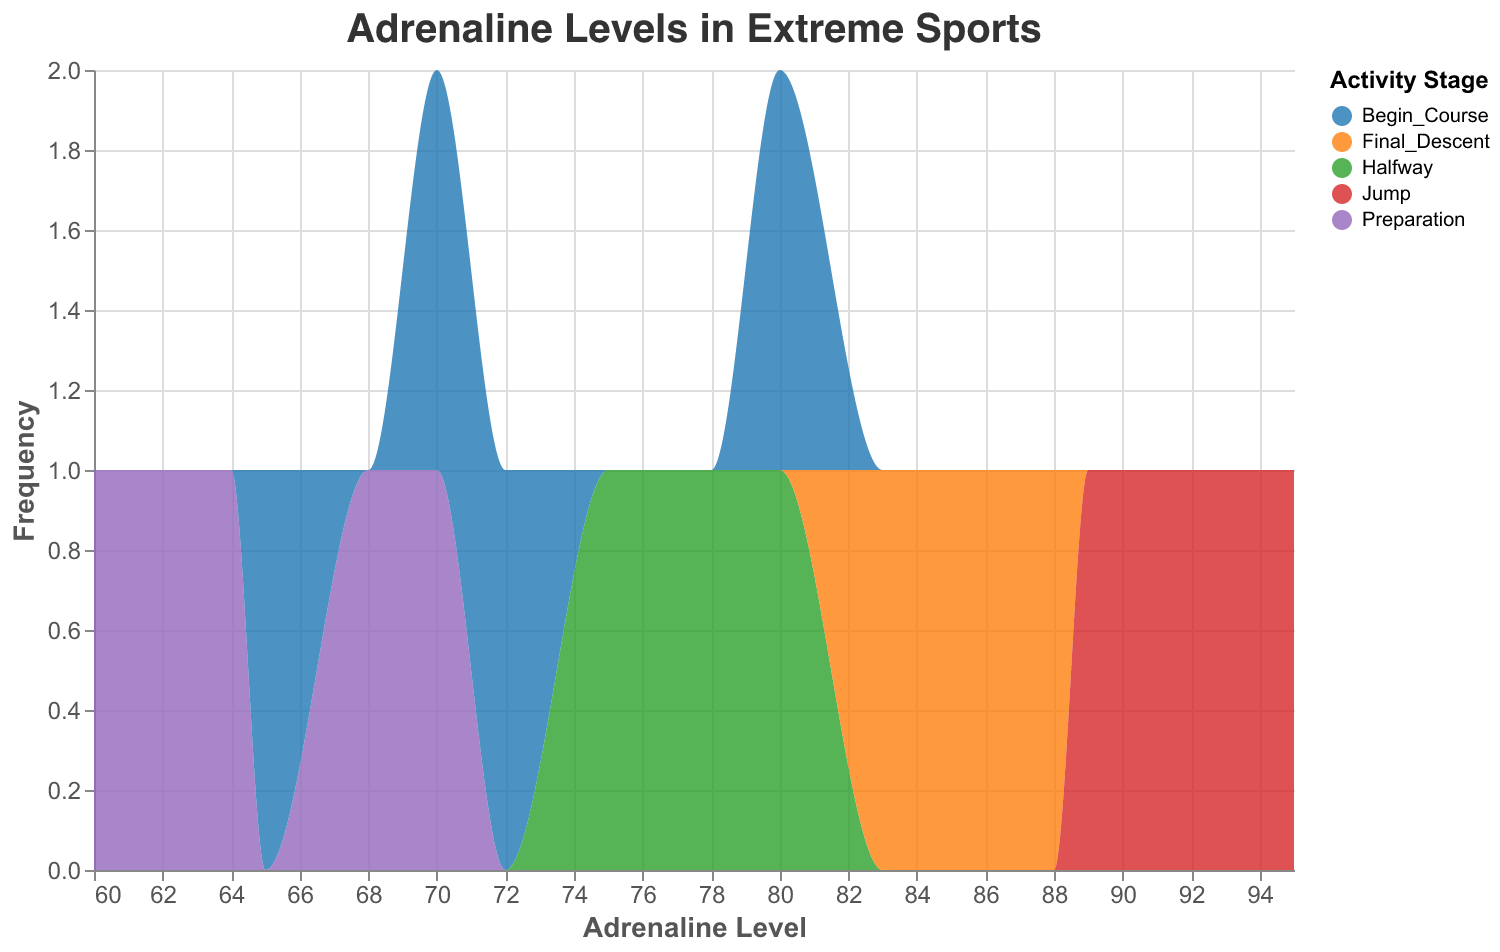What is the title of the figure? The title is a basic element of the figure. It is typically displayed at the top and clearly indicates the subject of the visualization.
Answer: Adrenaline Levels in Extreme Sports How many different activity stages are represented in the figure? Observing the legend or the color coding in the figure, each distinct color corresponds to a unique activity stage.
Answer: 5 Which activity stage has the highest recorded adrenaline level? By looking at the x-axis (Adrenaline Level) and observing where the highest value is, we can identify the corresponding activity stage through the color coding.
Answer: Jump During which activity stage are the adrenaline levels most frequently recorded between 85 and 95? By examining the distribution area on the figure within the range of 85-95 on the x-axis (Adrenaline Level), we can observe which activity stage's color dominates within this interval.
Answer: Jump What is the difference between the highest and lowest recorded adrenaline levels? To find the difference, identify the maximum value and minimum value on the x-axis, then subtract the minimum from the maximum. Maximum adrenaline level seen is 95, and minimum is 60, so the difference is 95 - 60.
Answer: 35 Which activity stage shows the widest spread of adrenaline levels? Looking for the span of the curve for each activity stage along the x-axis (Adrenaline Level), we indicate which color (activity stage) covers the most range.
Answer: Halfway Is the frequency of adrenaline levels more spread out or concentrated for the "Preparation" stage? By assessing the figure, especially the y-axis representing frequency and observing the color segment for "Preparation" stage, we can see if the area is narrow and high (concentrated) or wide and low (spread out).
Answer: Spread out How does the distribution of adrenaline levels for "Final Descent" compare to "Begin Course"? To compare the distributions, look at the areas under the curve for both stages and their shapes. "Final Descent" tends to have higher adrenaline levels more often compared to "Begin Course".
Answer: Final Descent has higher adrenaline levels more frequently What is the approximate average adrenaline level for the "Jump" stage? Estimate the average by finding the midpoint of the range where most "Jump" adrenaline levels fall. Peak frequencies for "Jump" range around 88-95, so averaging them gives about (88+95)/2.
Answer: Approximately 91.5 What is the median adrenaline level in the "Halfway" stage? A median in a distribution indicates the middle value. By examining the distribution for "Halfway", identify the central value where the frequency splits evenly.
Answer: Approximately 76 